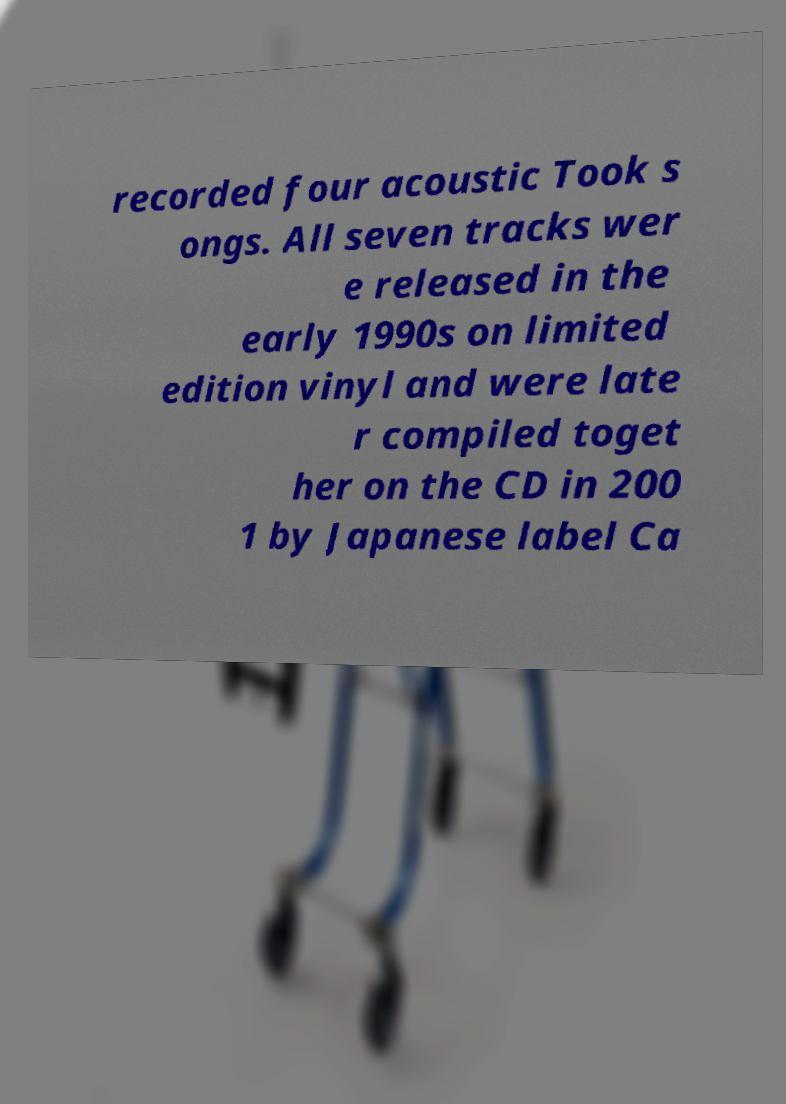Could you extract and type out the text from this image? recorded four acoustic Took s ongs. All seven tracks wer e released in the early 1990s on limited edition vinyl and were late r compiled toget her on the CD in 200 1 by Japanese label Ca 